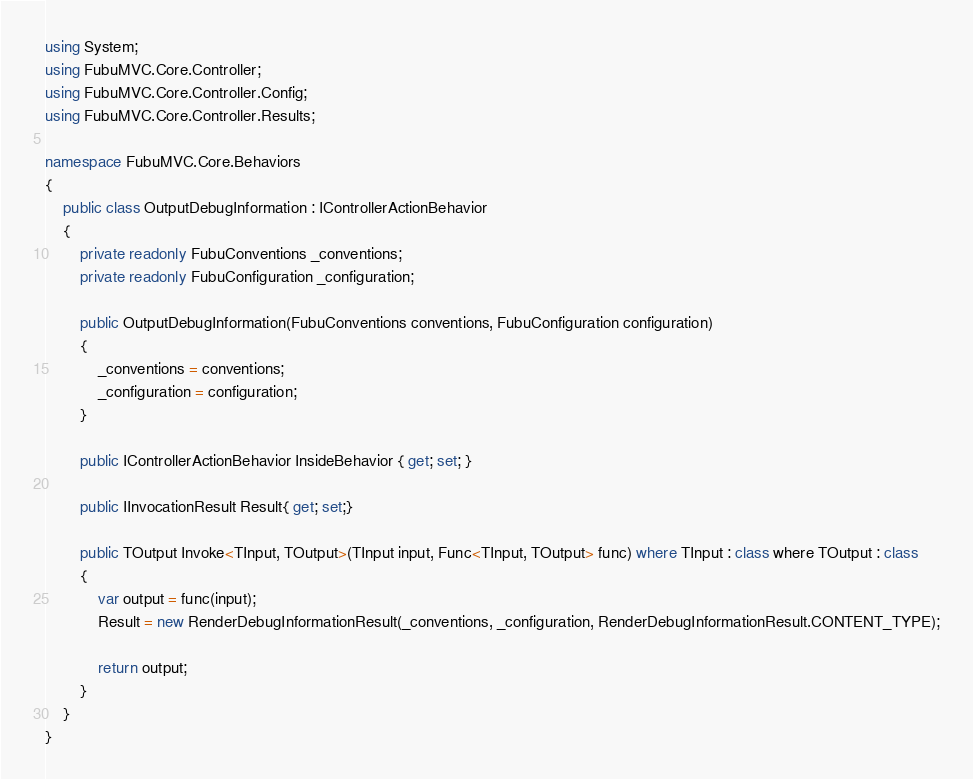Convert code to text. <code><loc_0><loc_0><loc_500><loc_500><_C#_>using System;
using FubuMVC.Core.Controller;
using FubuMVC.Core.Controller.Config;
using FubuMVC.Core.Controller.Results;

namespace FubuMVC.Core.Behaviors
{
    public class OutputDebugInformation : IControllerActionBehavior
    {
        private readonly FubuConventions _conventions;
        private readonly FubuConfiguration _configuration;

        public OutputDebugInformation(FubuConventions conventions, FubuConfiguration configuration)
        {
            _conventions = conventions;
            _configuration = configuration;
        }

        public IControllerActionBehavior InsideBehavior { get; set; }

        public IInvocationResult Result{ get; set;}

        public TOutput Invoke<TInput, TOutput>(TInput input, Func<TInput, TOutput> func) where TInput : class where TOutput : class
        {
            var output = func(input);
            Result = new RenderDebugInformationResult(_conventions, _configuration, RenderDebugInformationResult.CONTENT_TYPE);

            return output;
        }
    }
}</code> 